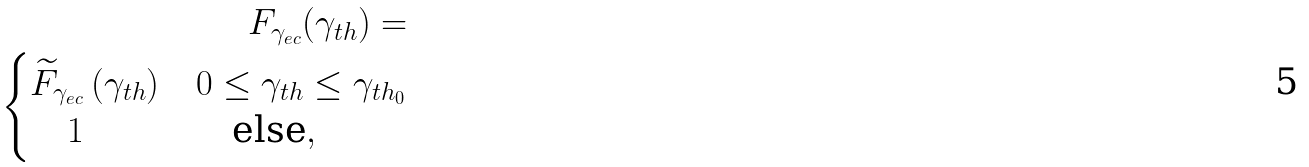Convert formula to latex. <formula><loc_0><loc_0><loc_500><loc_500>F _ { \gamma _ { e c } } ( \gamma _ { t h } ) = \\ \begin{cases} \widetilde { F } _ { \gamma _ { e c } } \, ( \gamma _ { t h } ) & 0 \leq \gamma _ { t h } \leq \gamma _ { t h _ { 0 } } \\ \quad 1 & \quad \text {else} , \\ \end{cases}</formula> 